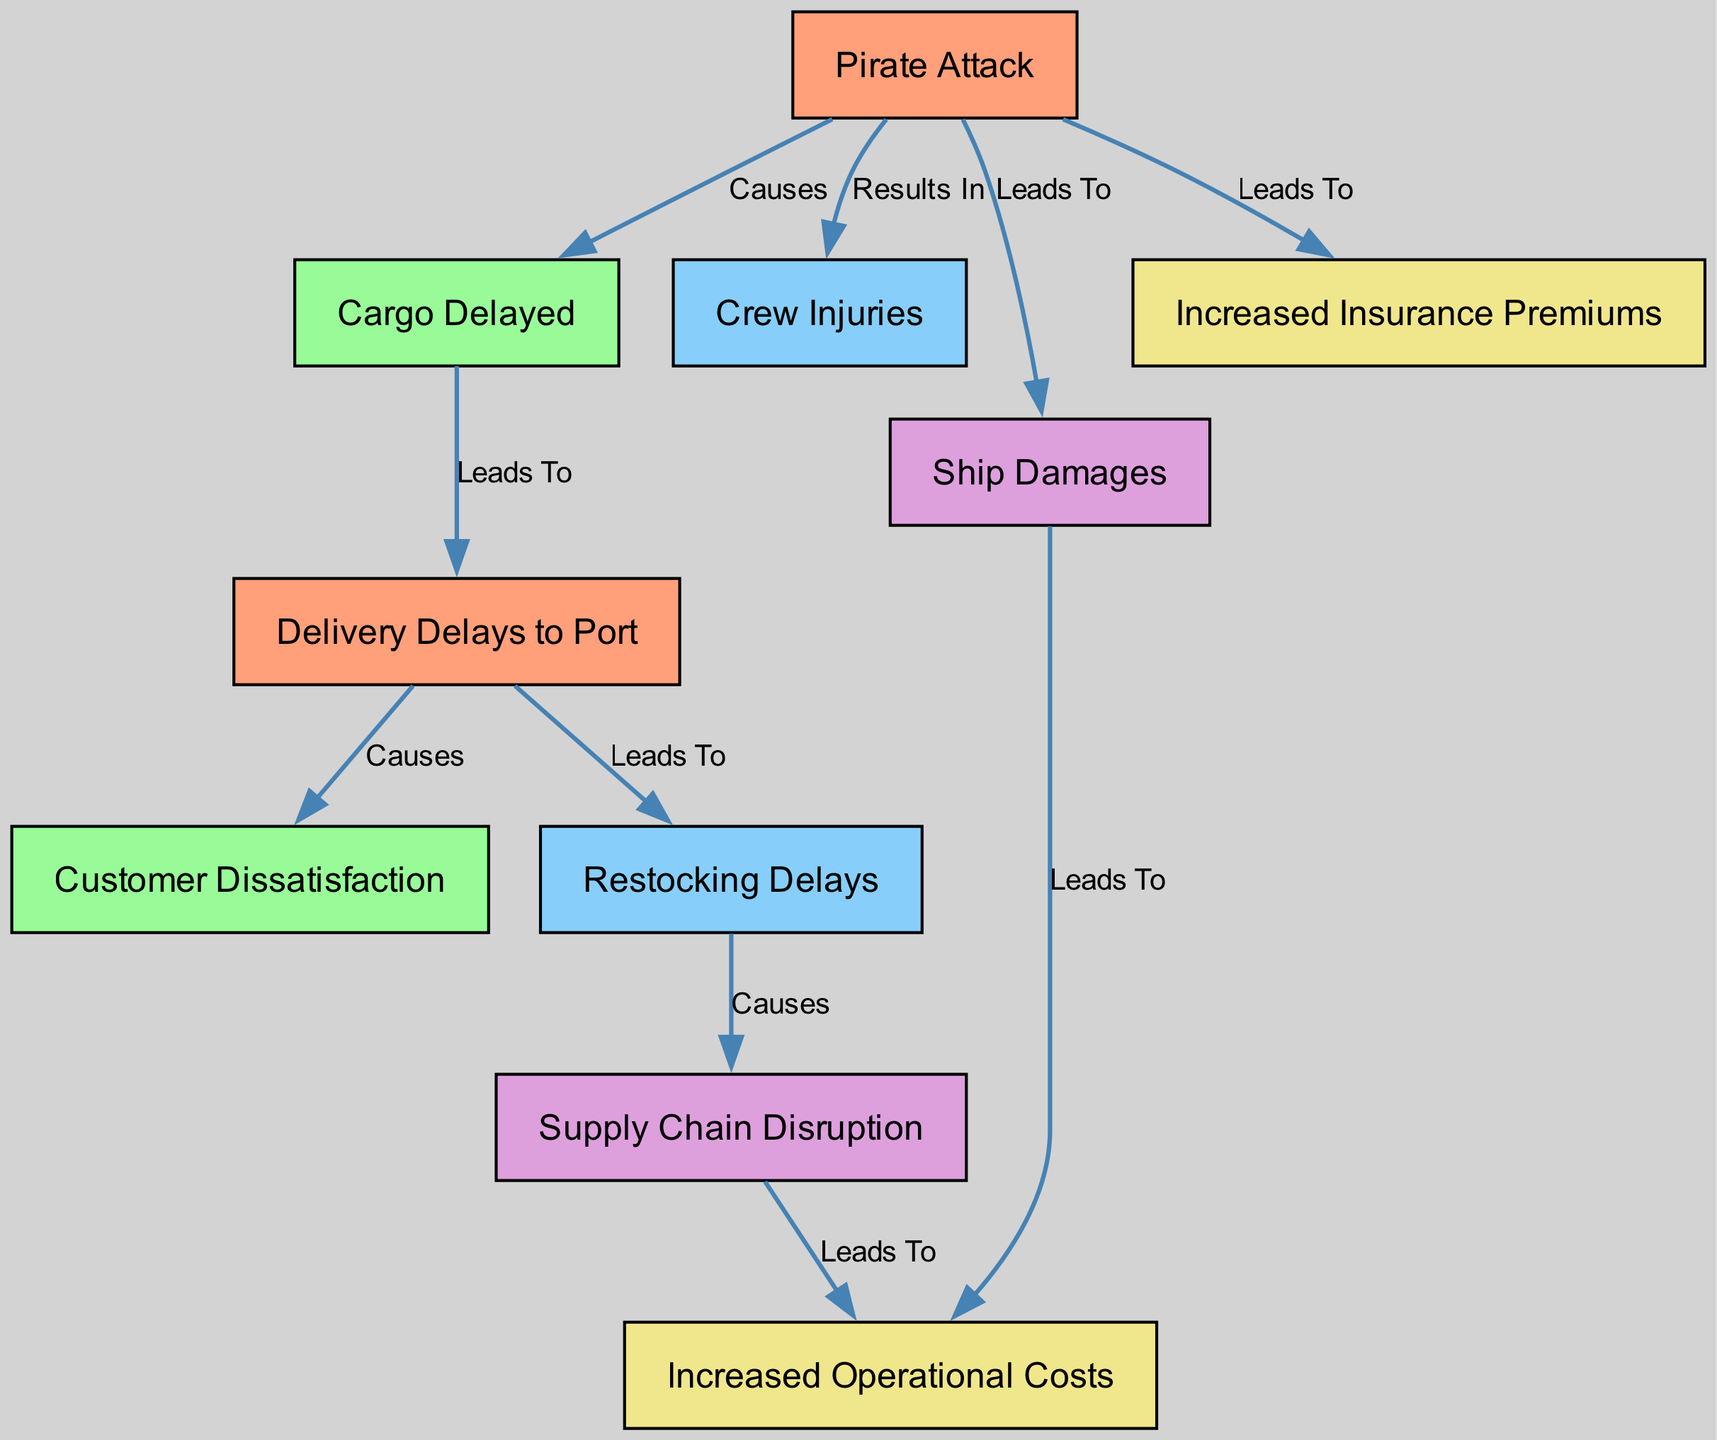What node directly follows "Pirate Attack"? The diagram shows that "Cargo Delayed" is the first node that directly follows "Pirate Attack," indicating that the occurrence of a pirate attack immediately results in delayed cargo.
Answer: Cargo Delayed How many nodes are present in the diagram? By counting the nodes listed in the data, there are a total of ten nodes indicating various impacts and results originating from the pirate attack.
Answer: Ten What causes "Customer Dissatisfaction"? The diagram specifies that "Delivery Delays to Port" leads to "Customer Dissatisfaction," meaning that the delays in delivery due to a pirate attack directly result in customers being dissatisfied.
Answer: Delivery Delays to Port Which node leads to increased operational costs? The diagram indicates that "Ship Damages" leads to "Increased Operational Costs," showing that the financial burden of ship repairs results directly from damages enacted during a pirate attack.
Answer: Ship Damages What are the two outcomes of a pirate attack related to crew safety? The diagram depicts that a pirate attack results in both "Crew Injuries" and "Ship Damages," highlighting the direct negative consequences on crew safety and the vessel itself.
Answer: Crew Injuries and Ship Damages What results from restocking delays? According to the diagram, "Restocking Delays" cause "Supply Chain Disruption." This implies that delays in the restocking process have a cascading effect, disturbing the overall supply chain.
Answer: Supply Chain Disruption What connections lead from "Cargo Delayed" to restocking operations? In the diagram, "Cargo Delayed" leads to "Delivery Delays to Port," which subsequently causes "Restocking Delays." Therefore, the delay in cargo affects both delivery and restocking efforts.
Answer: Delivery Delays to Port and Restocking Delays What directly links pirate attacks to increased insurance premiums? The diagram specifies that pirate attacks lead directly to "Increased Insurance Premiums," indicating a financial repercussion stemming from the elevated risk associated with such incidents.
Answer: Increased Insurance Premiums Which two nodes are consequences of "Ship Damages"? The consequences shown in the diagram for "Ship Damages" are "Increased Operational Costs" and "Increased Insurance Premiums," indicating financial impacts stemming from impairments to the ship.
Answer: Increased Operational Costs and Increased Insurance Premiums 